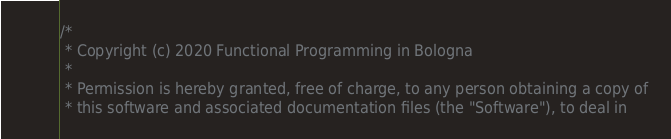Convert code to text. <code><loc_0><loc_0><loc_500><loc_500><_Scala_>/*
 * Copyright (c) 2020 Functional Programming in Bologna
 *
 * Permission is hereby granted, free of charge, to any person obtaining a copy of
 * this software and associated documentation files (the "Software"), to deal in</code> 